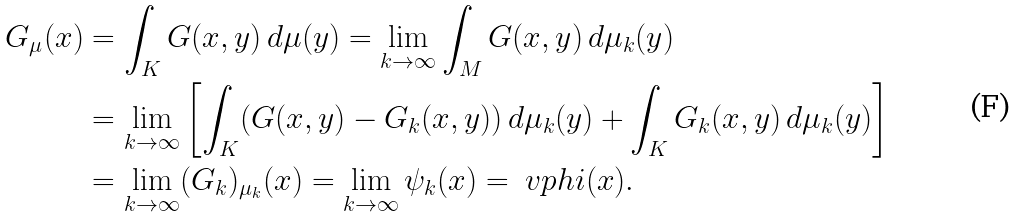<formula> <loc_0><loc_0><loc_500><loc_500>G _ { \mu } ( x ) & = \int _ { K } G ( x , y ) \, d \mu ( y ) = \lim _ { k \to \infty } \int _ { M } G ( x , y ) \, d \mu _ { k } ( y ) \\ & = \lim _ { k \to \infty } \left [ \int _ { K } ( G ( x , y ) - G _ { k } ( x , y ) ) \, d \mu _ { k } ( y ) + \int _ { K } G _ { k } ( x , y ) \, d \mu _ { k } ( y ) \right ] \\ & = \lim _ { k \to \infty } ( G _ { k } ) _ { \mu _ { k } } ( x ) = \lim _ { k \to \infty } \psi _ { k } ( x ) = \ v p h i ( x ) .</formula> 